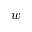<formula> <loc_0><loc_0><loc_500><loc_500>w</formula> 